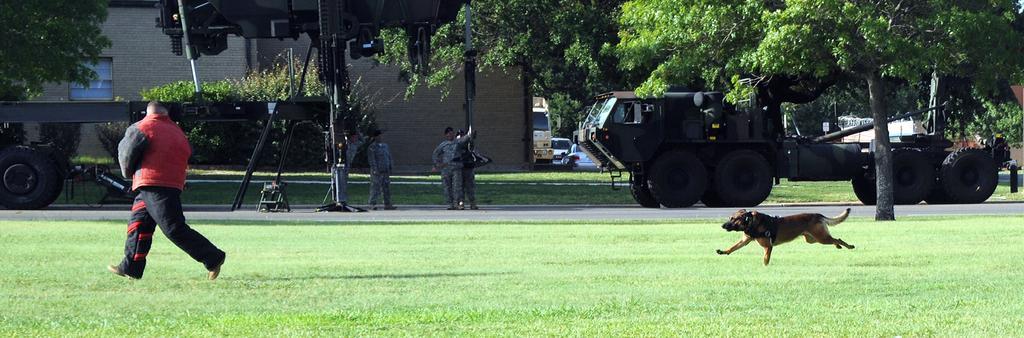Please provide a concise description of this image. A dog is running on the grass at the right. A man is running at the left side. There are people and vehicles on the road. There are trees and buildings at the back. 